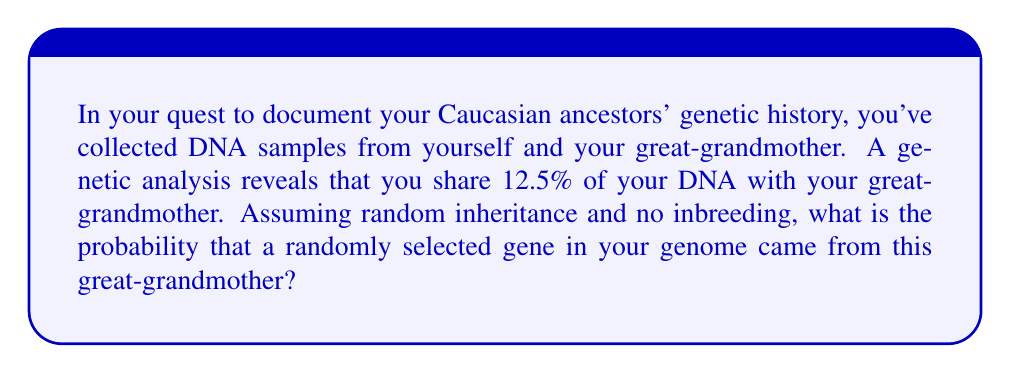Show me your answer to this math problem. To solve this problem, we need to understand the concept of genetic inheritance and how it relates to shared DNA percentages.

1. In genetic inheritance, a child receives 50% of their DNA from each parent.

2. This means that the percentage of shared DNA halves with each generation:
   - Parent-child: 50%
   - Grandparent-grandchild: 25%
   - Great-grandparent-great-grandchild: 12.5%

3. The question states that you share 12.5% of your DNA with your great-grandmother, which aligns with the expected percentage.

4. To calculate the probability that a randomly selected gene came from this great-grandmother, we can use the shared DNA percentage directly.

5. The probability is simply the percentage of shared DNA expressed as a decimal:

   $$P(\text{gene from great-grandmother}) = \frac{\text{Shared DNA percentage}}{100} = \frac{12.5}{100} = 0.125$$

6. This makes intuitive sense because if 12.5% of your genes come from your great-grandmother, then the probability of randomly selecting one of those genes is also 12.5%.
Answer: The probability that a randomly selected gene in your genome came from this great-grandmother is $0.125$ or $\frac{1}{8}$. 